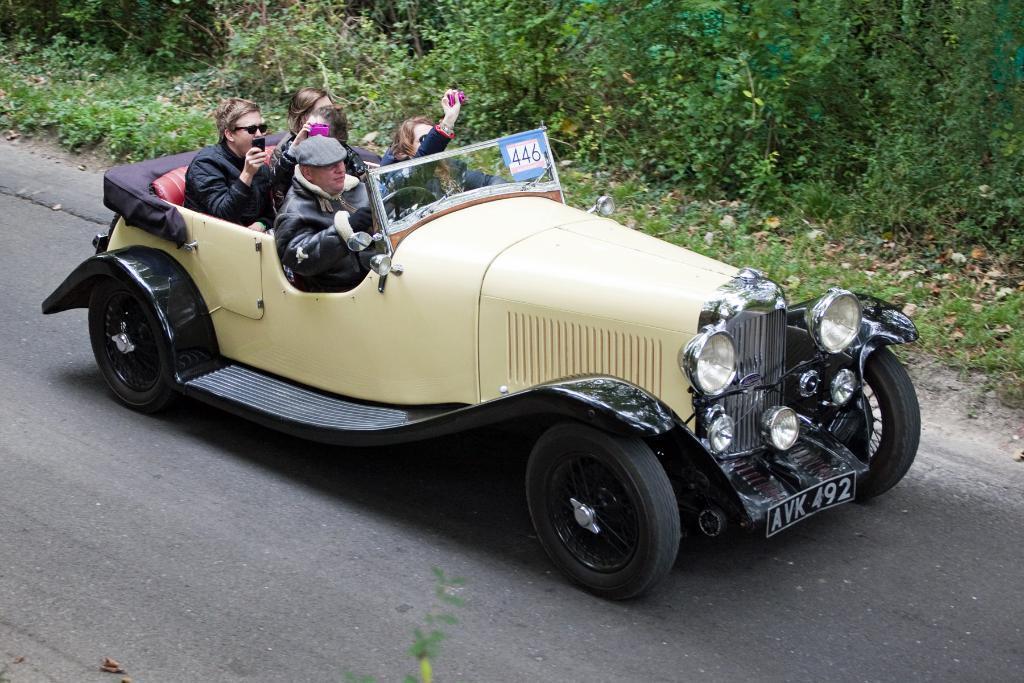Describe this image in one or two sentences. Here we can see a group of people travelling in a Vintage car on a road and beside them we can see plants present 